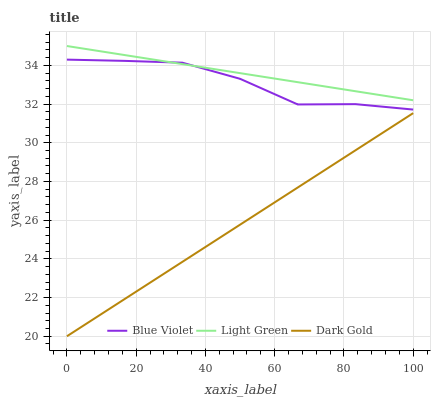Does Dark Gold have the minimum area under the curve?
Answer yes or no. Yes. Does Light Green have the maximum area under the curve?
Answer yes or no. Yes. Does Blue Violet have the minimum area under the curve?
Answer yes or no. No. Does Blue Violet have the maximum area under the curve?
Answer yes or no. No. Is Dark Gold the smoothest?
Answer yes or no. Yes. Is Blue Violet the roughest?
Answer yes or no. Yes. Is Blue Violet the smoothest?
Answer yes or no. No. Is Dark Gold the roughest?
Answer yes or no. No. Does Dark Gold have the lowest value?
Answer yes or no. Yes. Does Blue Violet have the lowest value?
Answer yes or no. No. Does Light Green have the highest value?
Answer yes or no. Yes. Does Blue Violet have the highest value?
Answer yes or no. No. Is Dark Gold less than Blue Violet?
Answer yes or no. Yes. Is Blue Violet greater than Dark Gold?
Answer yes or no. Yes. Does Light Green intersect Blue Violet?
Answer yes or no. Yes. Is Light Green less than Blue Violet?
Answer yes or no. No. Is Light Green greater than Blue Violet?
Answer yes or no. No. Does Dark Gold intersect Blue Violet?
Answer yes or no. No. 